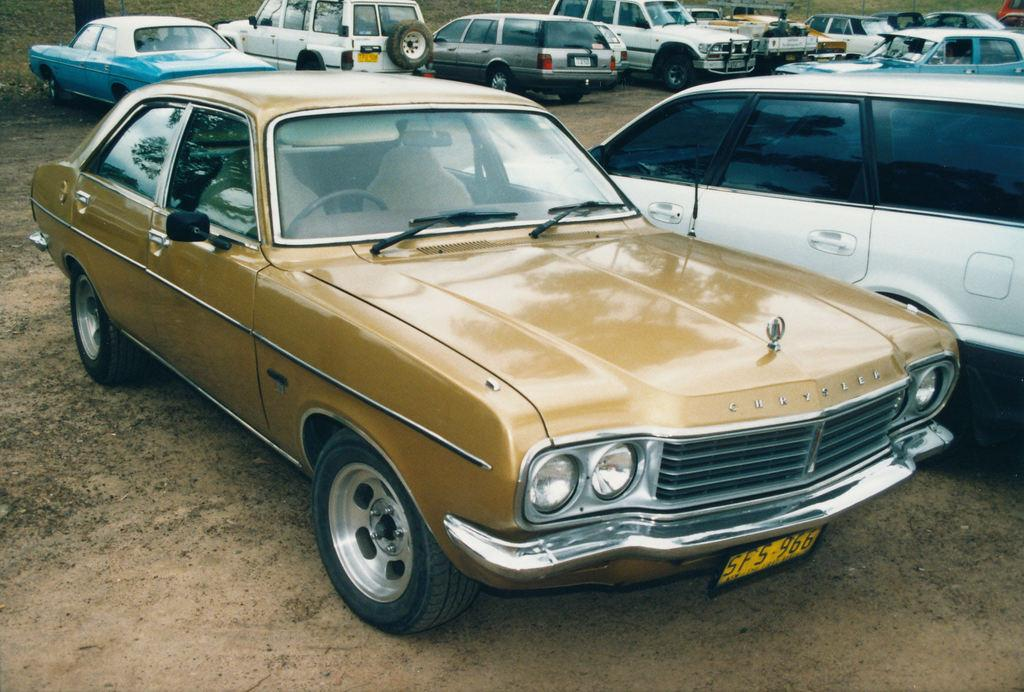What types of transportation are present in the image? There are vehicles in the image. Can you describe the natural element in the image? There is a tree at the left top of the image. How many frogs can be seen sitting on the vehicles in the image? There are no frogs present in the image; it only features vehicles and a tree. 